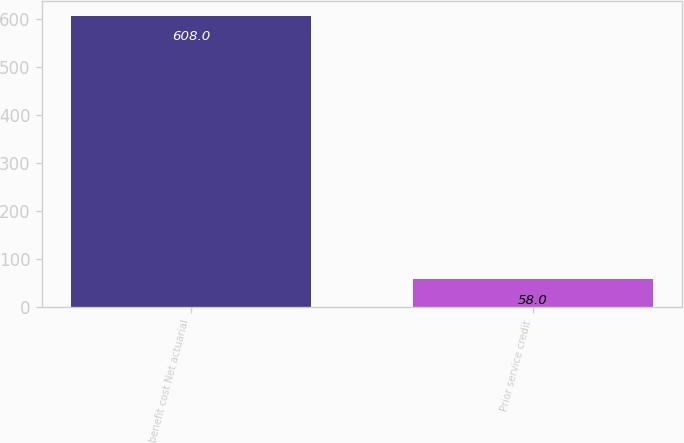<chart> <loc_0><loc_0><loc_500><loc_500><bar_chart><fcel>benefit cost Net actuarial<fcel>Prior service credit<nl><fcel>608<fcel>58<nl></chart> 